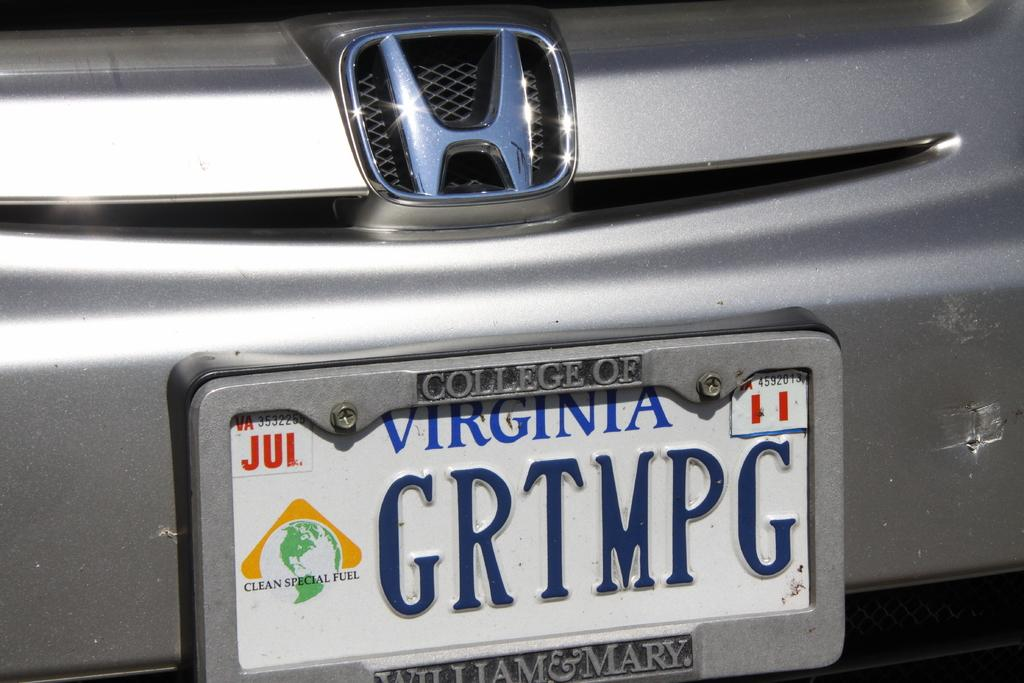What is there is a specific type of vehicle shown in the image? The image is a zoom-in picture of a car. What color is the car in the image? The car is grey in color. Can you identify any specific details about the car in the image? There is a nameplate visible in the image. How many chickens are visible in the image? There are no chickens present in the image; it features a zoom-in picture of a grey car with a nameplate. What type of fowl can be seen interacting with the car in the image? There is no fowl present in the image; it only shows a car with a nameplate. 